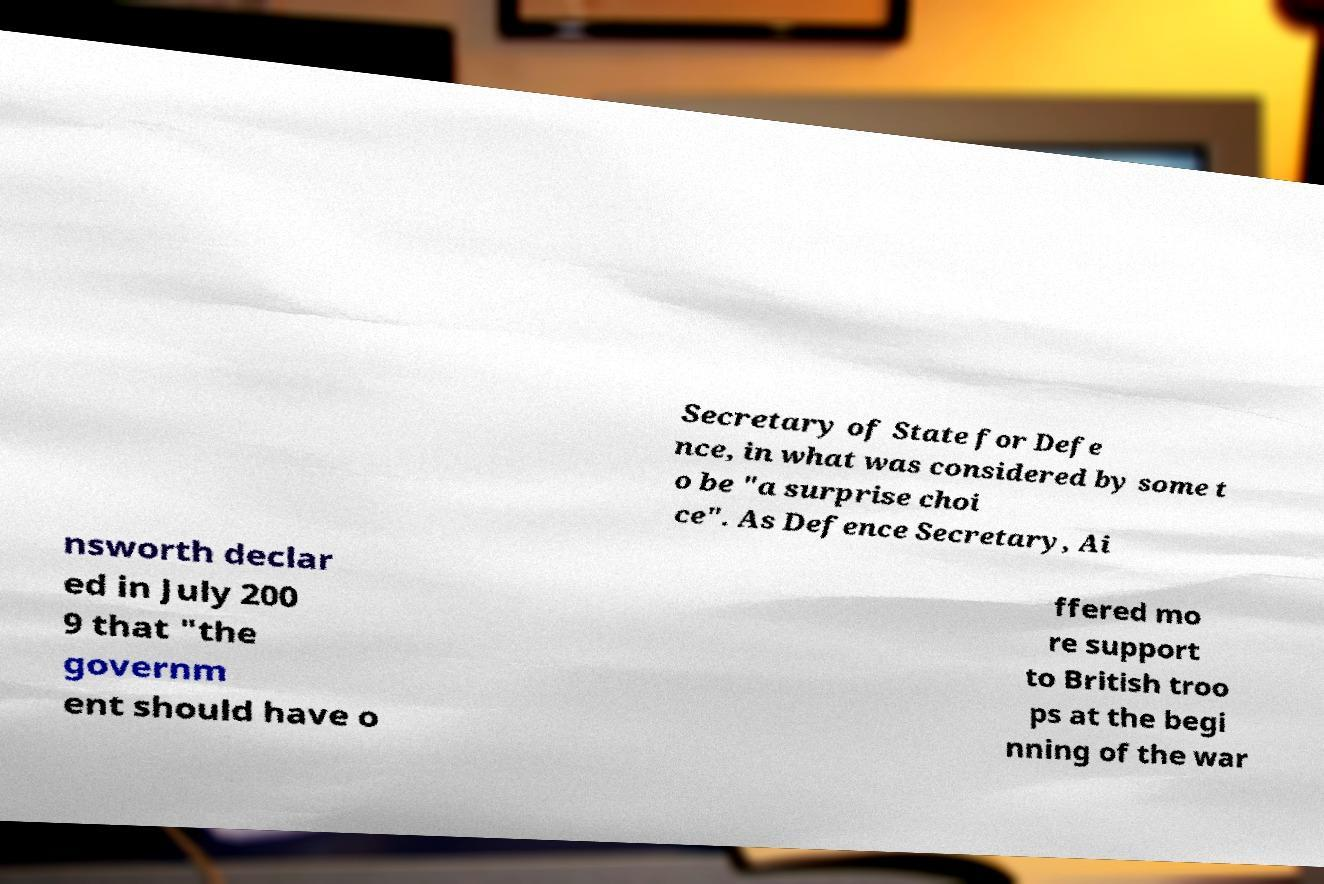There's text embedded in this image that I need extracted. Can you transcribe it verbatim? Secretary of State for Defe nce, in what was considered by some t o be "a surprise choi ce". As Defence Secretary, Ai nsworth declar ed in July 200 9 that "the governm ent should have o ffered mo re support to British troo ps at the begi nning of the war 